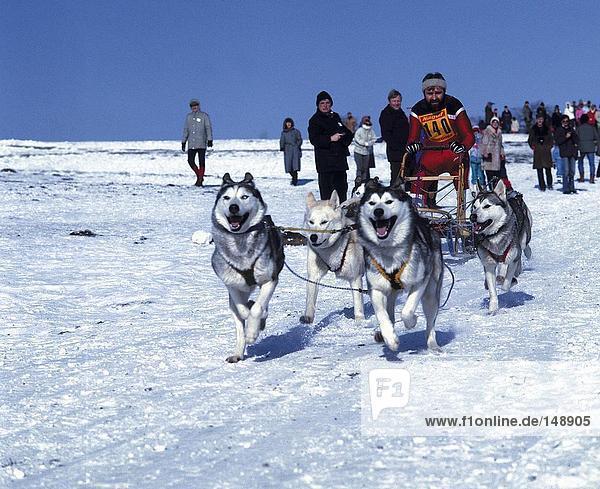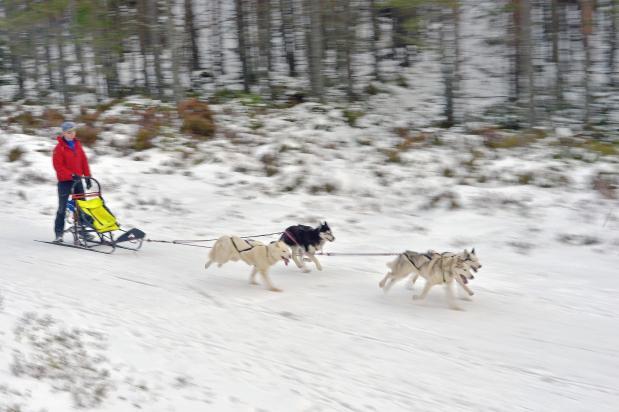The first image is the image on the left, the second image is the image on the right. Given the left and right images, does the statement "Both images show at least one sled pulled by no more than five dogs." hold true? Answer yes or no. Yes. The first image is the image on the left, the second image is the image on the right. Given the left and right images, does the statement "The combined images contain three teams of sled dogs running forward across the snow instead of away from the camera." hold true? Answer yes or no. No. 